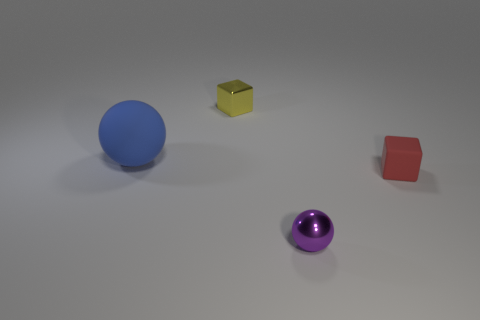Is there anything else that has the same material as the large ball?
Provide a succinct answer. Yes. Are there any large blue matte objects?
Ensure brevity in your answer.  Yes. There is a metal block; is its color the same as the tiny shiny thing right of the metallic cube?
Your response must be concise. No. There is a matte thing left of the metallic object that is in front of the tiny cube that is to the right of the small yellow object; what size is it?
Keep it short and to the point. Large. How many other big spheres are the same color as the metallic sphere?
Keep it short and to the point. 0. What number of objects are brown metal objects or blocks that are behind the large matte ball?
Provide a succinct answer. 1. What is the color of the metal sphere?
Give a very brief answer. Purple. There is a metal thing that is behind the small red matte object; what color is it?
Offer a very short reply. Yellow. How many tiny yellow shiny cubes are on the right side of the shiny object that is to the left of the tiny purple metal thing?
Make the answer very short. 0. There is a blue matte object; is it the same size as the object in front of the small red cube?
Provide a succinct answer. No. 